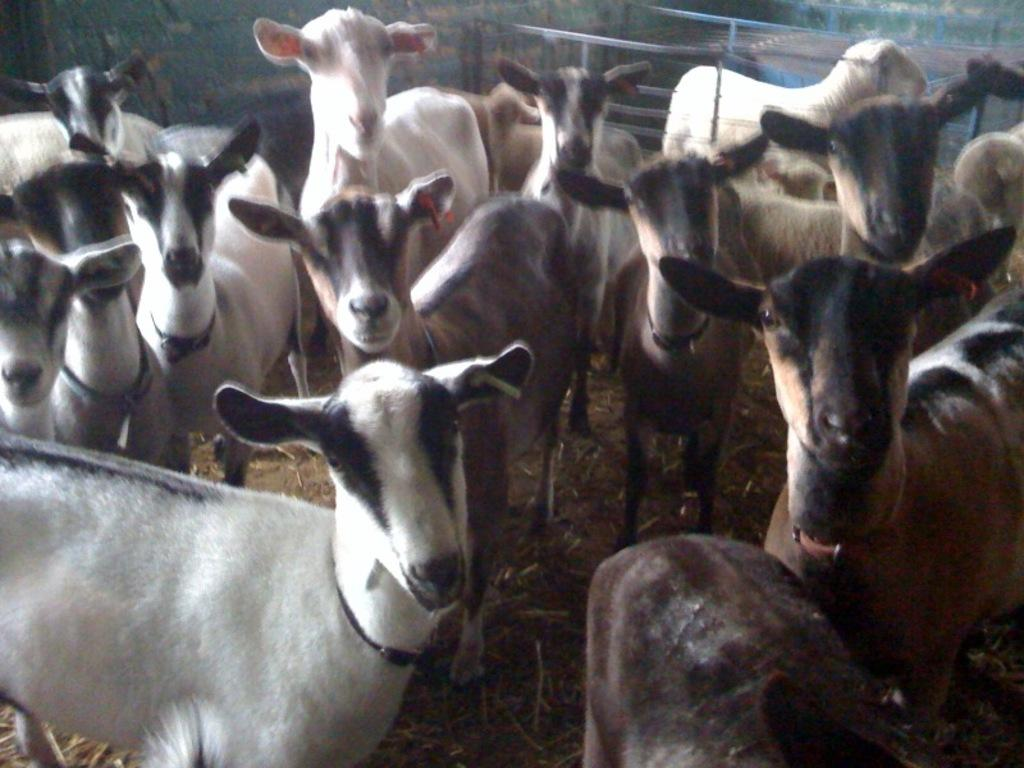What animals are present in the image? There are goats in the image. What can be observed about the appearance of the goats? The goats are in different colors. What is the goats' location in the image? The goats are standing on dry grass. What can be seen on the ground in the image? The ground is visible in the image. What is present in the background of the image? There is fencing, trees, and other objects in the background of the image. Where is the faucet located in the image? There is no faucet present in the image. What type of string is being used by the goats in the image? There is no string being used by the goats in the image. 